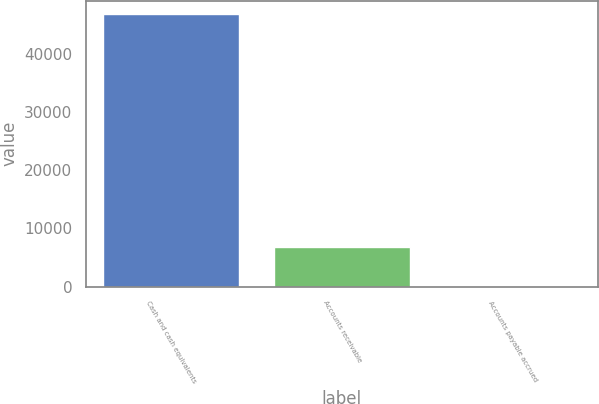Convert chart. <chart><loc_0><loc_0><loc_500><loc_500><bar_chart><fcel>Cash and cash equivalents<fcel>Accounts receivable<fcel>Accounts payable accrued<nl><fcel>46739<fcel>6751<fcel>88<nl></chart> 